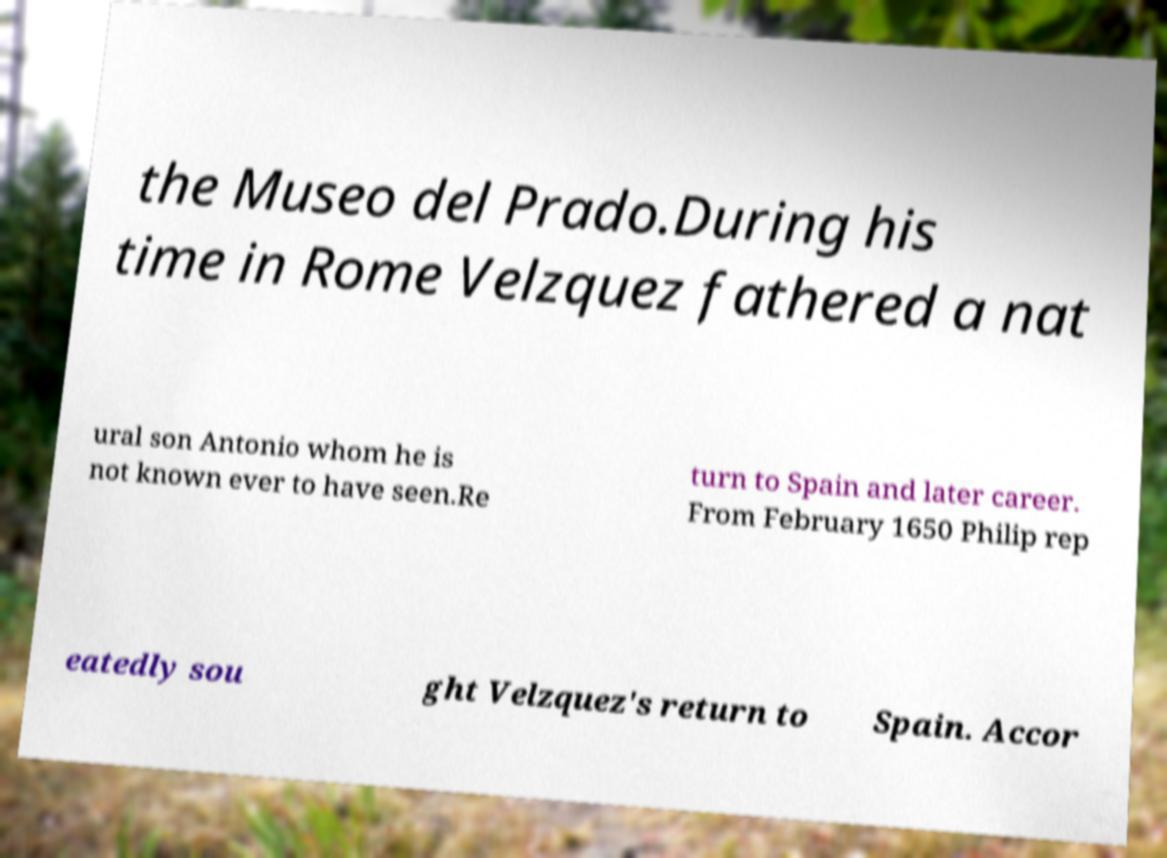I need the written content from this picture converted into text. Can you do that? the Museo del Prado.During his time in Rome Velzquez fathered a nat ural son Antonio whom he is not known ever to have seen.Re turn to Spain and later career. From February 1650 Philip rep eatedly sou ght Velzquez's return to Spain. Accor 